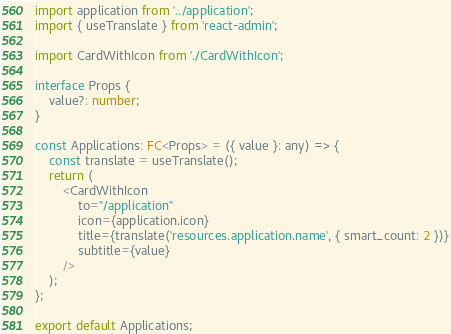<code> <loc_0><loc_0><loc_500><loc_500><_TypeScript_>import application from '../application';
import { useTranslate } from 'react-admin';

import CardWithIcon from './CardWithIcon';

interface Props {
    value?: number;
}

const Applications: FC<Props> = ({ value }: any) => {
    const translate = useTranslate();
    return (
        <CardWithIcon
            to="/application"
            icon={application.icon}
            title={translate('resources.application.name', { smart_count: 2 })}
            subtitle={value}
        />
    );
};

export default Applications;
</code> 